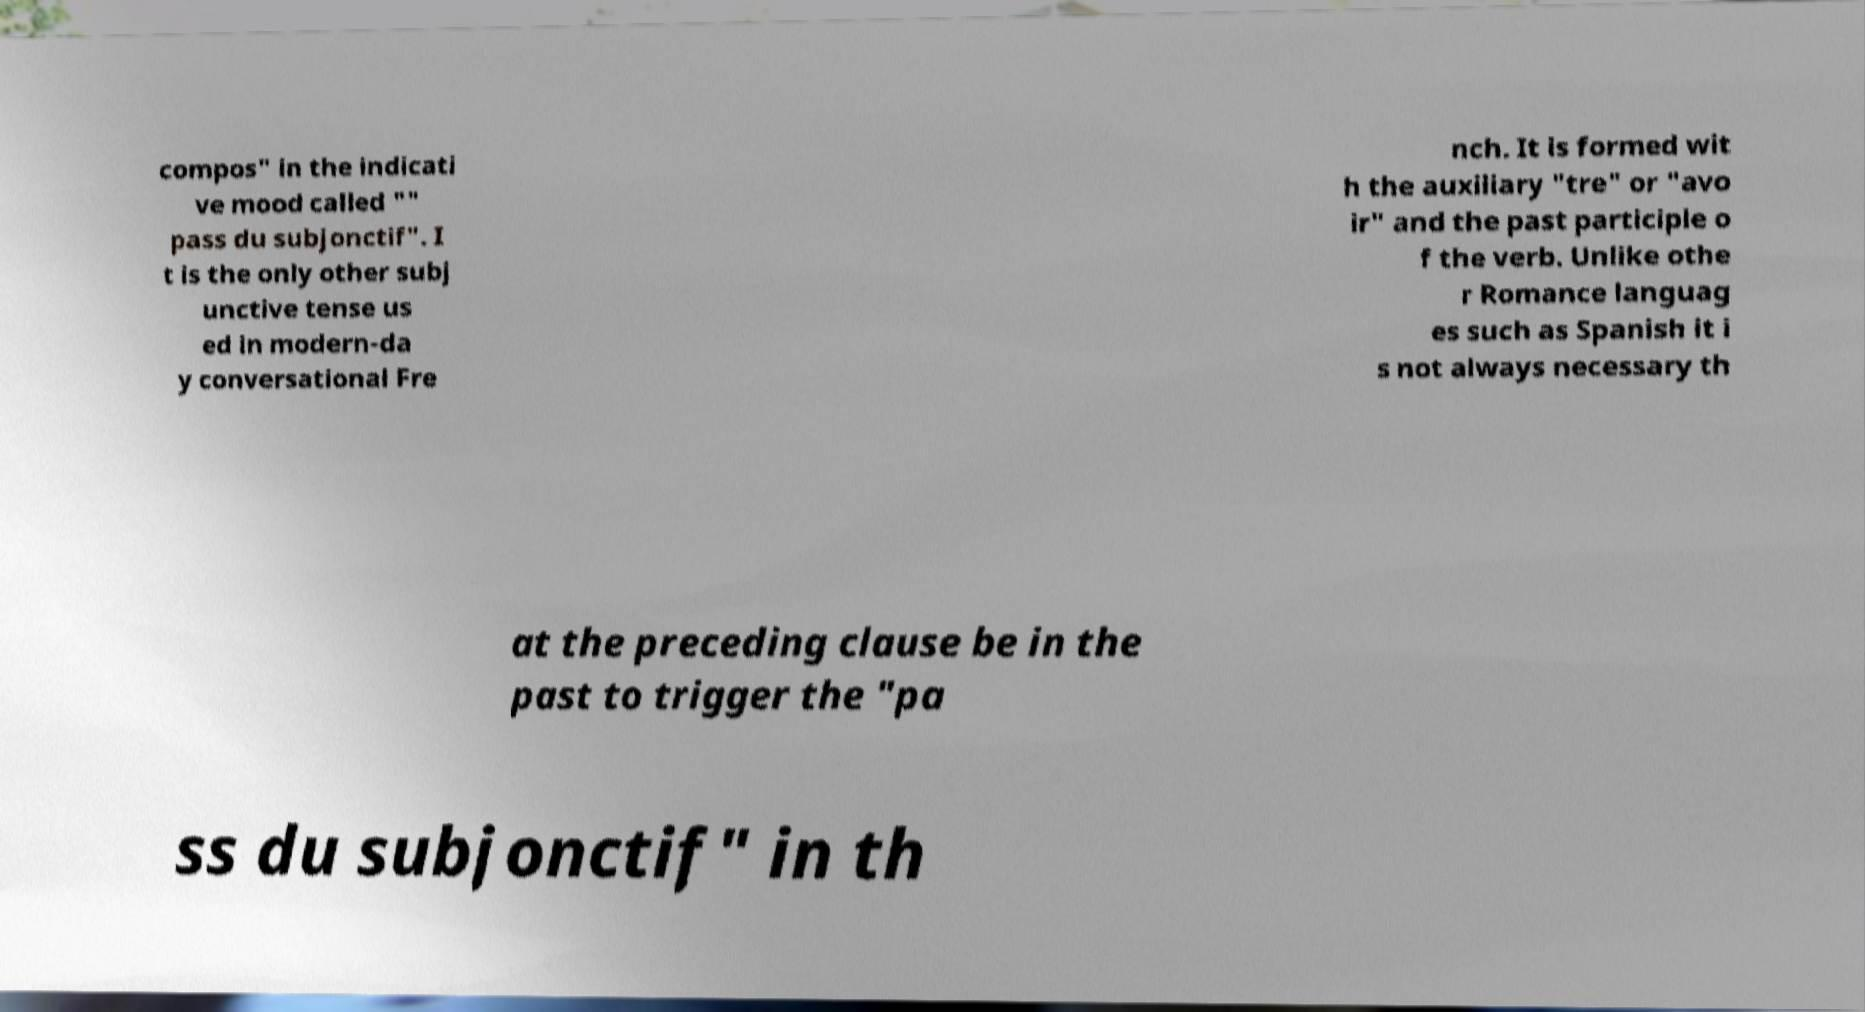Can you accurately transcribe the text from the provided image for me? compos" in the indicati ve mood called "" pass du subjonctif". I t is the only other subj unctive tense us ed in modern-da y conversational Fre nch. It is formed wit h the auxiliary "tre" or "avo ir" and the past participle o f the verb. Unlike othe r Romance languag es such as Spanish it i s not always necessary th at the preceding clause be in the past to trigger the "pa ss du subjonctif" in th 